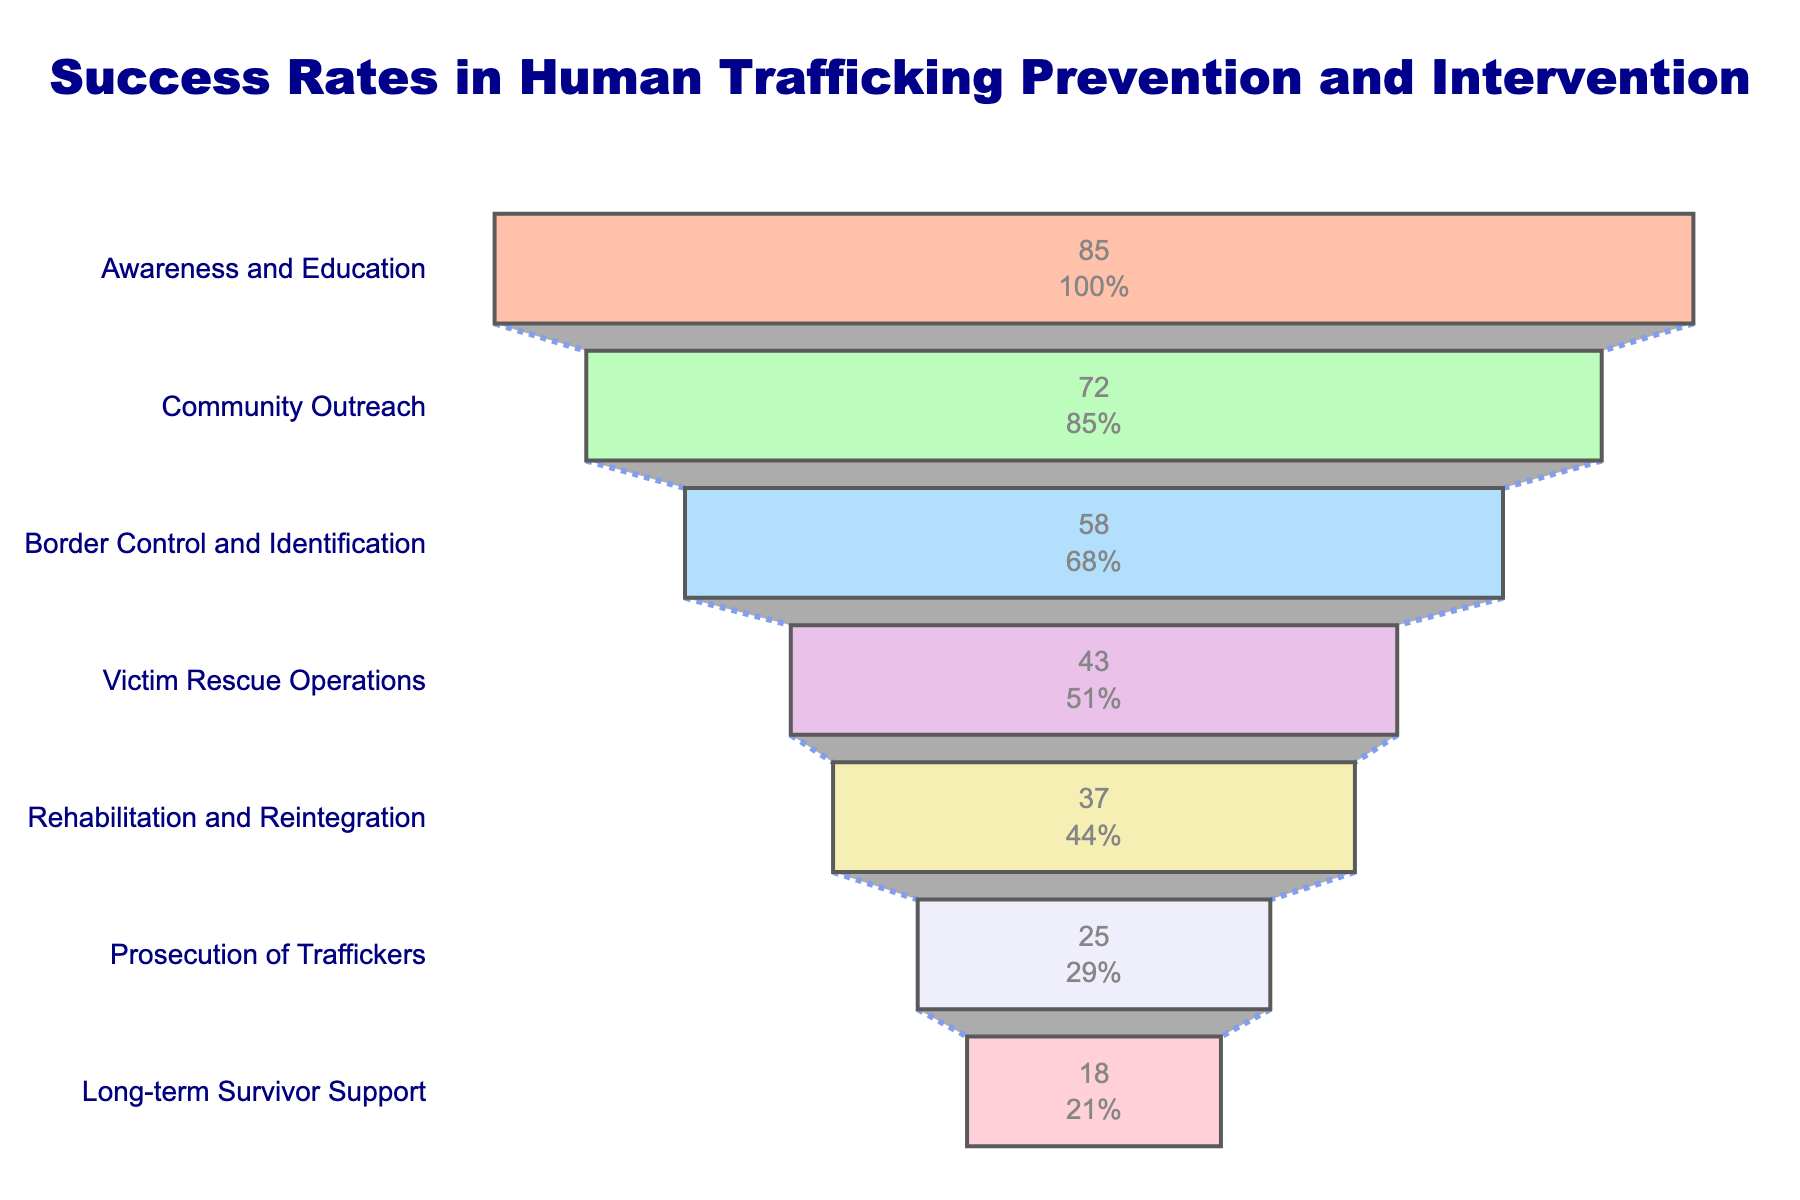What is the title of the figure? The title is located at the top center of the chart.
Answer: Success Rates in Human Trafficking Prevention and Intervention How many stages are represented in the funnel chart? Count the number of distinct stages listed on the y-axis.
Answer: Seven Which stage has the highest success rate? Identify the stage at the top of the funnel with the largest segment.
Answer: Awareness and Education Which stage has the lowest success rate? Identify the stage at the bottom of the funnel with the smallest segment.
Answer: Long-term Survivor Support How much higher is the success rate of 'Community Outreach' compared to 'Prosecution of Traffickers'? Find the success rates for both stages and calculate the difference: 72 (Community Outreach) - 25 (Prosecution of Traffickers).
Answer: 47 What is the average success rate of 'Border Control and Identification' and 'Victim Rescue Operations'? Calculate the average of 58 (Border Control and Identification) and 43 (Victim Rescue Operations). \[(58 + 43)/2 = 50.5\]
Answer: 50.5 Which stage has a success rate of 37%? Identify the stage corresponding to the 37% success rate.
Answer: Rehabilitation and Reintegration How many stages have a success rate equal to or above 50%? Count the number of stages where the success rate is 50% or higher.
Answer: Three What is the cumulative success rate of 'Victim Rescue Operations', 'Rehabilitation and Reintegration', and 'Prosecution of Traffickers'? Add the success rates of the mentioned stages: 43 + 37 + 25.
Answer: 105 Is the success rate of 'Border Control and Identification' greater than or less than 'Community Outreach'? Compare the success rates of the two stages: 58 (Border Control and Identification) vs. 72 (Community Outreach).
Answer: Less than 